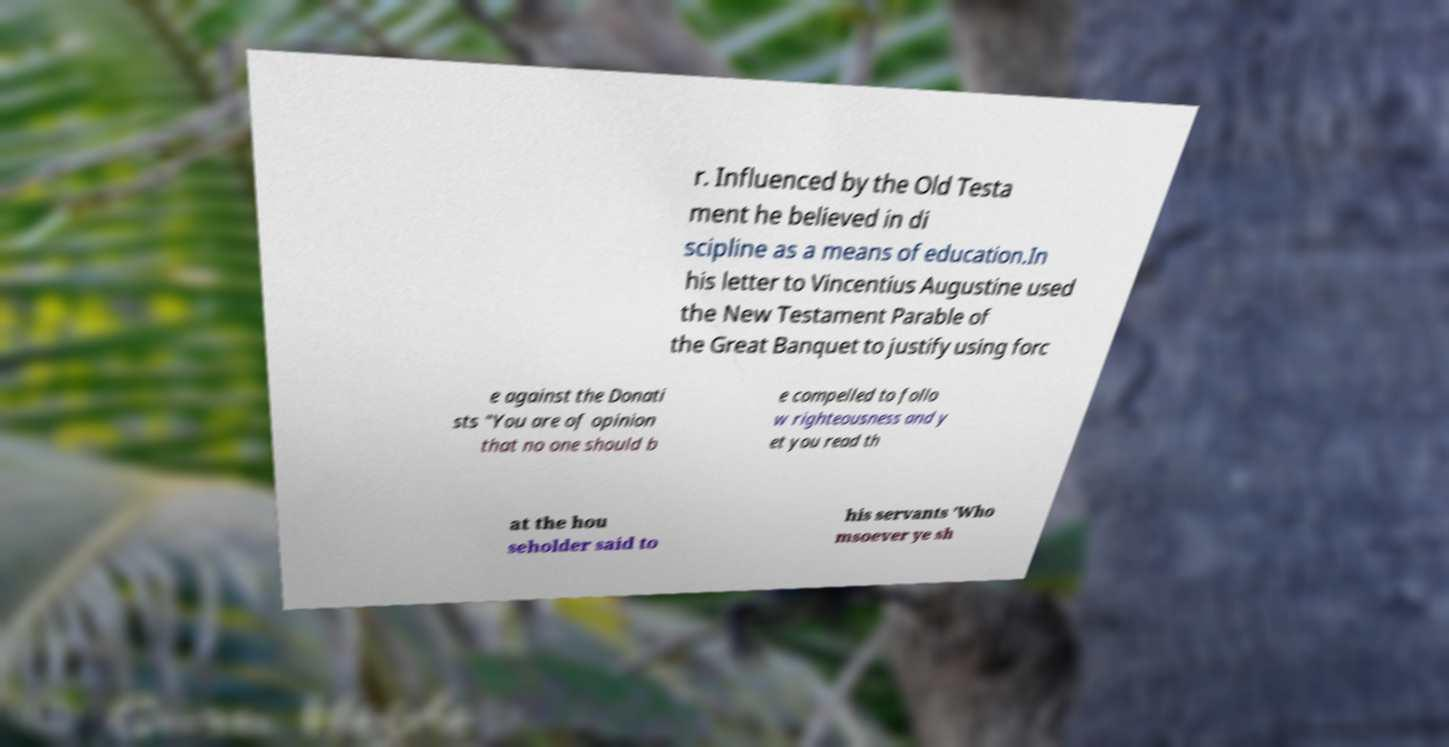Please read and relay the text visible in this image. What does it say? r. Influenced by the Old Testa ment he believed in di scipline as a means of education.In his letter to Vincentius Augustine used the New Testament Parable of the Great Banquet to justify using forc e against the Donati sts "You are of opinion that no one should b e compelled to follo w righteousness and y et you read th at the hou seholder said to his servants 'Who msoever ye sh 